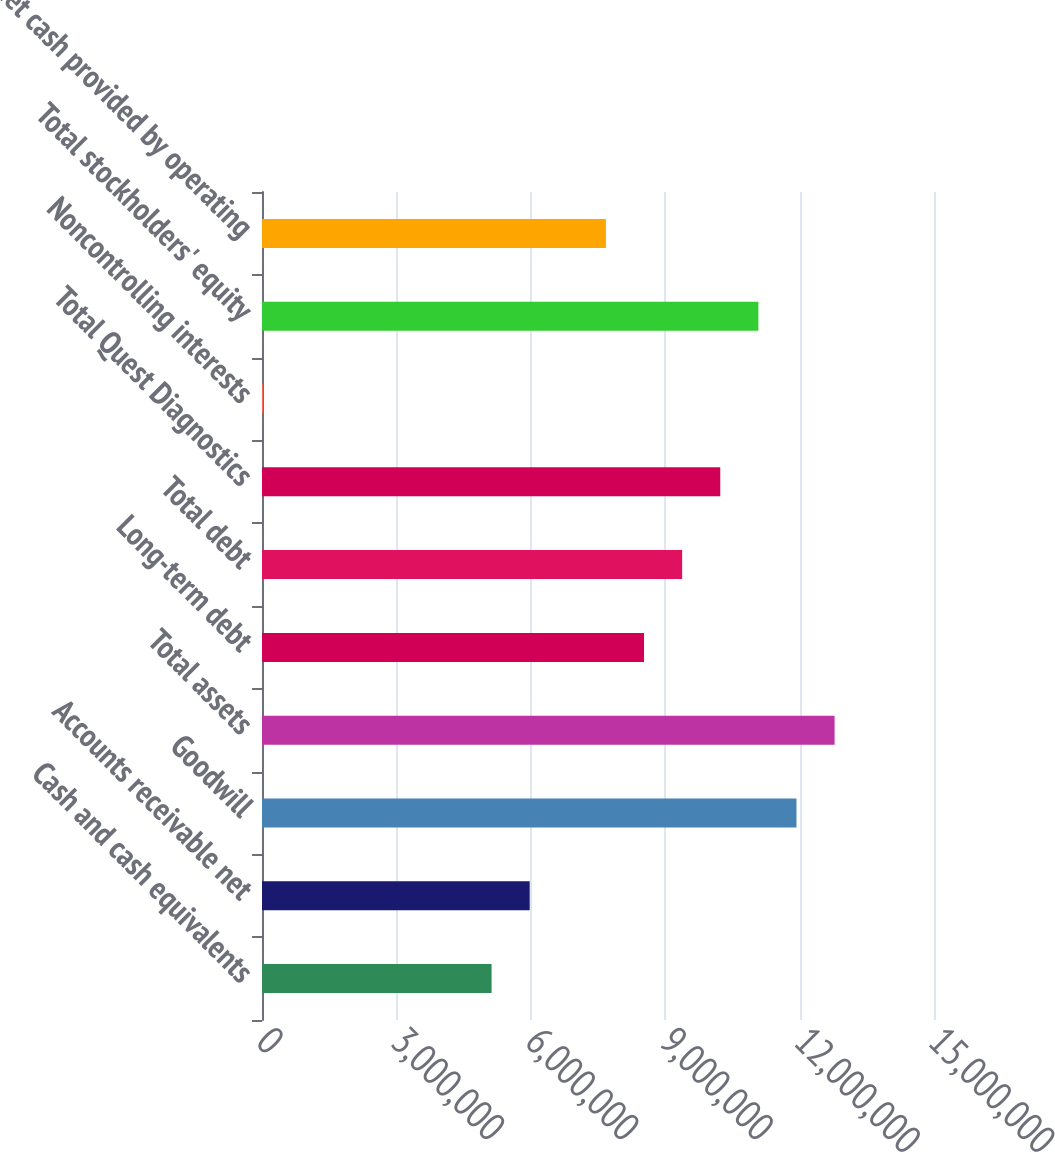<chart> <loc_0><loc_0><loc_500><loc_500><bar_chart><fcel>Cash and cash equivalents<fcel>Accounts receivable net<fcel>Goodwill<fcel>Total assets<fcel>Long-term debt<fcel>Total debt<fcel>Total Quest Diagnostics<fcel>Noncontrolling interests<fcel>Total stockholders' equity<fcel>Net cash provided by operating<nl><fcel>5.12484e+06<fcel>5.97553e+06<fcel>1.19304e+07<fcel>1.27811e+07<fcel>8.52763e+06<fcel>9.37833e+06<fcel>1.0229e+07<fcel>20645<fcel>1.10797e+07<fcel>7.67693e+06<nl></chart> 